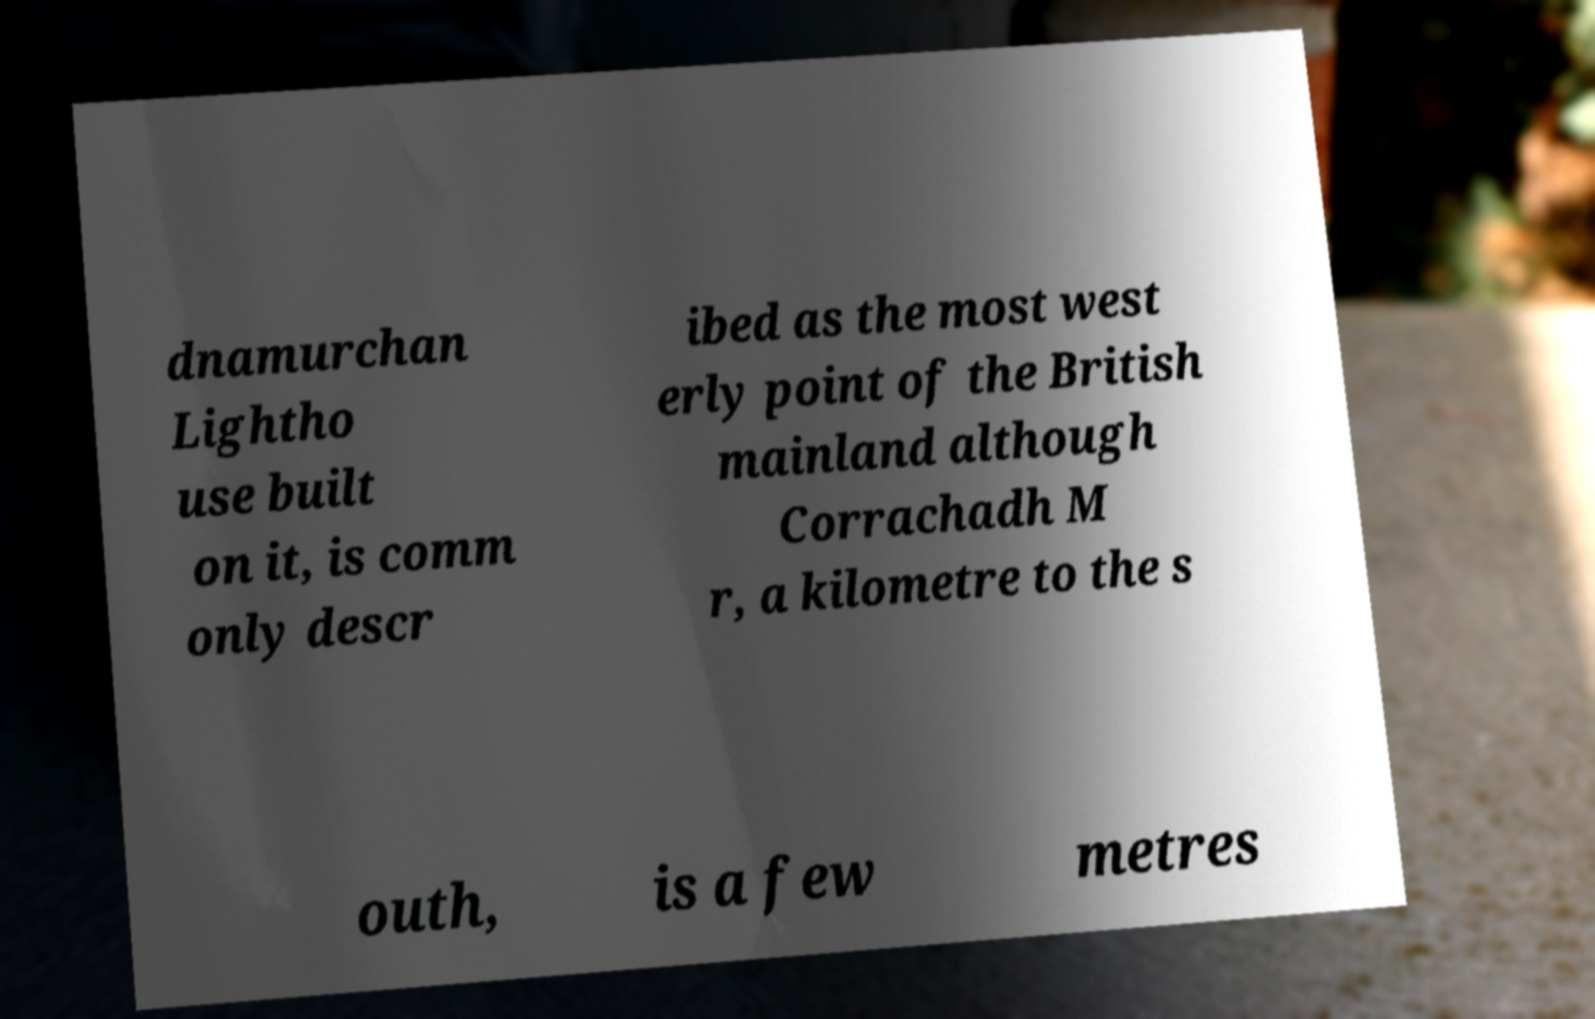What messages or text are displayed in this image? I need them in a readable, typed format. dnamurchan Lightho use built on it, is comm only descr ibed as the most west erly point of the British mainland although Corrachadh M r, a kilometre to the s outh, is a few metres 